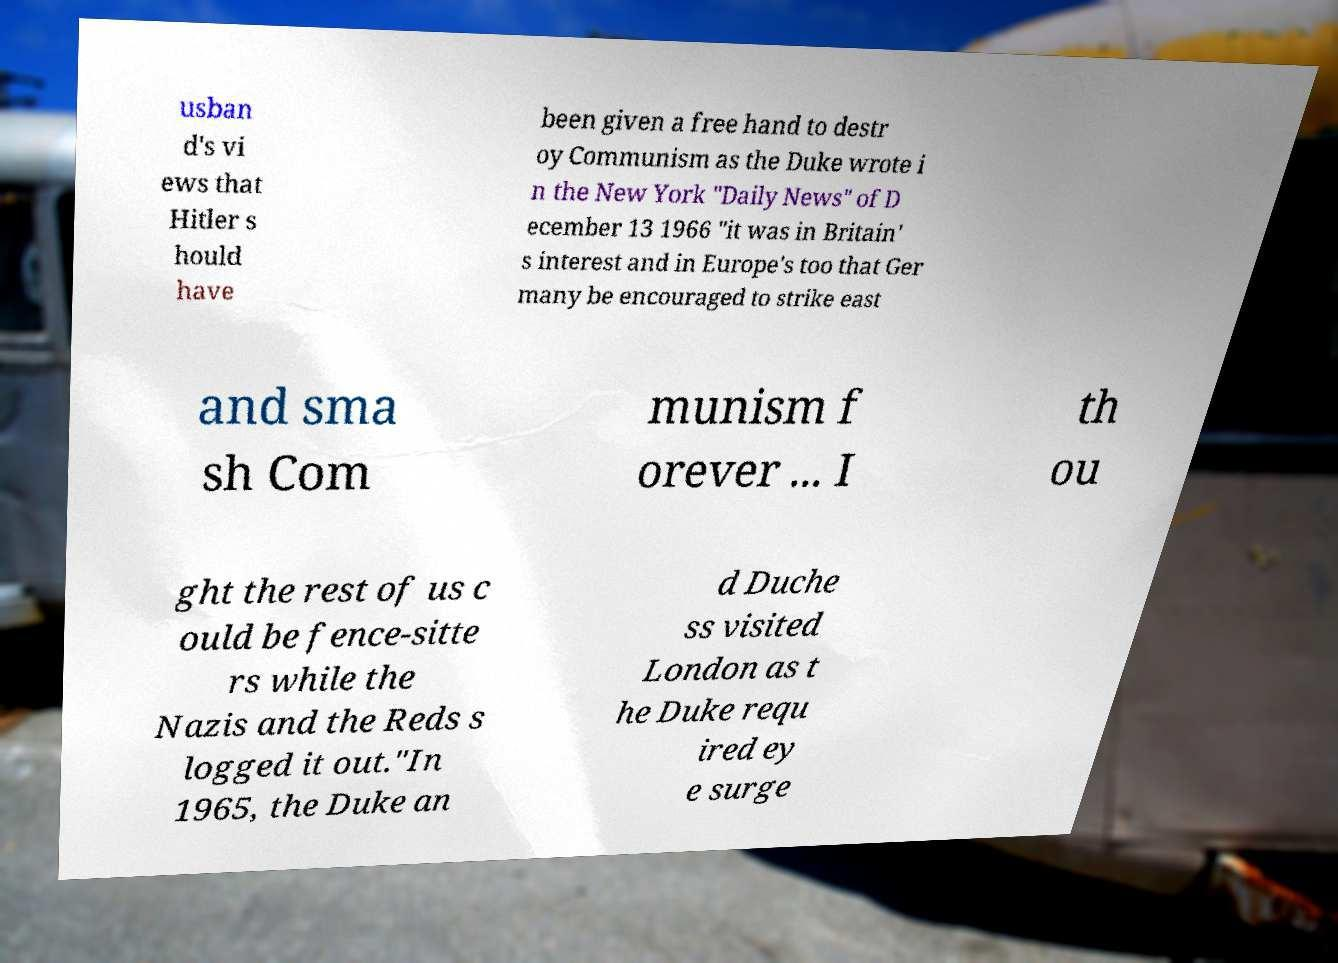Please identify and transcribe the text found in this image. usban d's vi ews that Hitler s hould have been given a free hand to destr oy Communism as the Duke wrote i n the New York "Daily News" of D ecember 13 1966 "it was in Britain' s interest and in Europe's too that Ger many be encouraged to strike east and sma sh Com munism f orever ... I th ou ght the rest of us c ould be fence-sitte rs while the Nazis and the Reds s logged it out."In 1965, the Duke an d Duche ss visited London as t he Duke requ ired ey e surge 